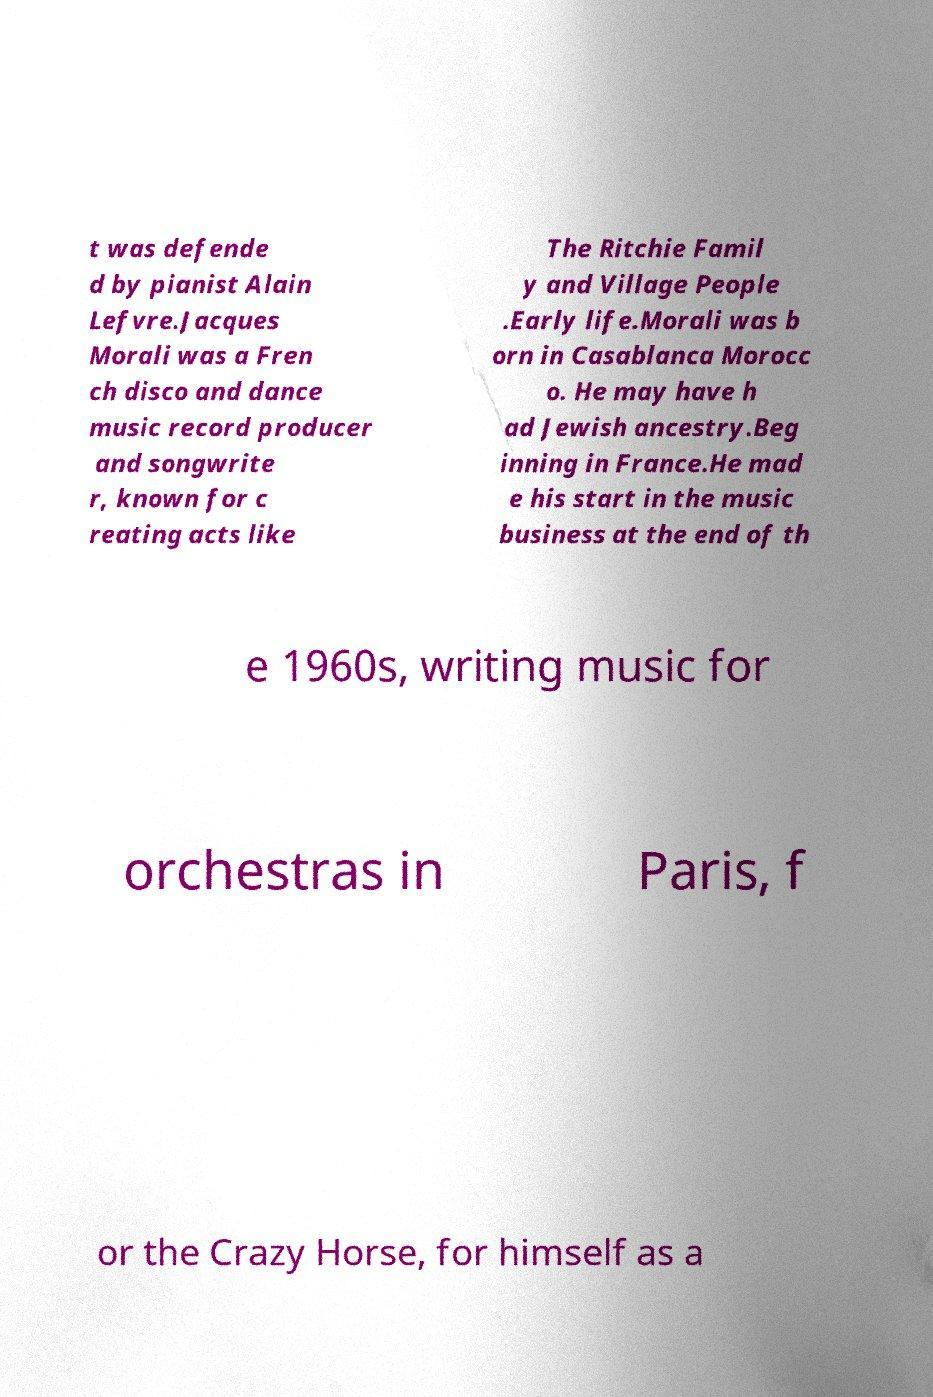Please read and relay the text visible in this image. What does it say? t was defende d by pianist Alain Lefvre.Jacques Morali was a Fren ch disco and dance music record producer and songwrite r, known for c reating acts like The Ritchie Famil y and Village People .Early life.Morali was b orn in Casablanca Morocc o. He may have h ad Jewish ancestry.Beg inning in France.He mad e his start in the music business at the end of th e 1960s, writing music for orchestras in Paris, f or the Crazy Horse, for himself as a 